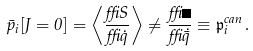Convert formula to latex. <formula><loc_0><loc_0><loc_500><loc_500>\bar { p } _ { i } [ J = 0 ] = \left < \frac { \delta S } { \delta \dot { q } } \right > \neq \frac { \delta \Gamma } { \delta \dot { \bar { q } } } \equiv \mathfrak { p } _ { i } ^ { c a n } \, .</formula> 